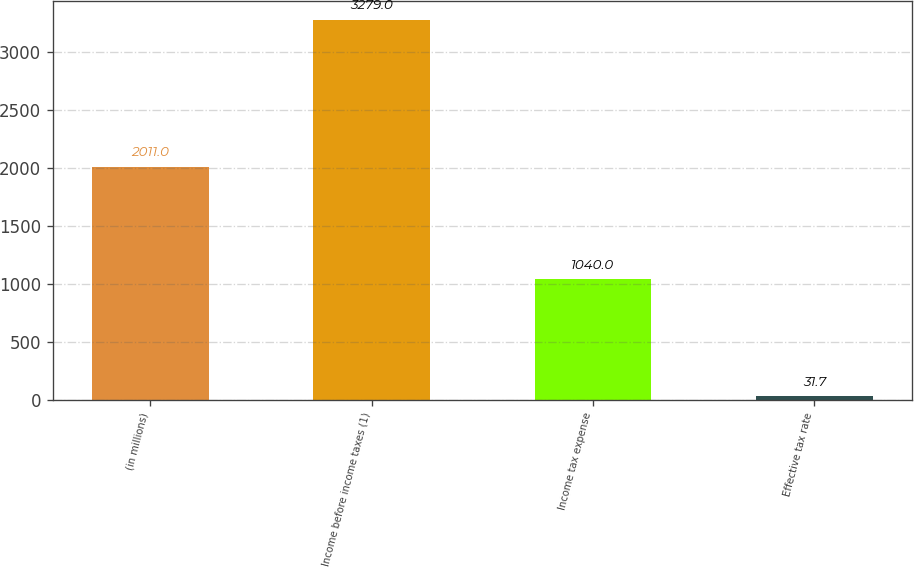Convert chart to OTSL. <chart><loc_0><loc_0><loc_500><loc_500><bar_chart><fcel>(in millions)<fcel>Income before income taxes (1)<fcel>Income tax expense<fcel>Effective tax rate<nl><fcel>2011<fcel>3279<fcel>1040<fcel>31.7<nl></chart> 